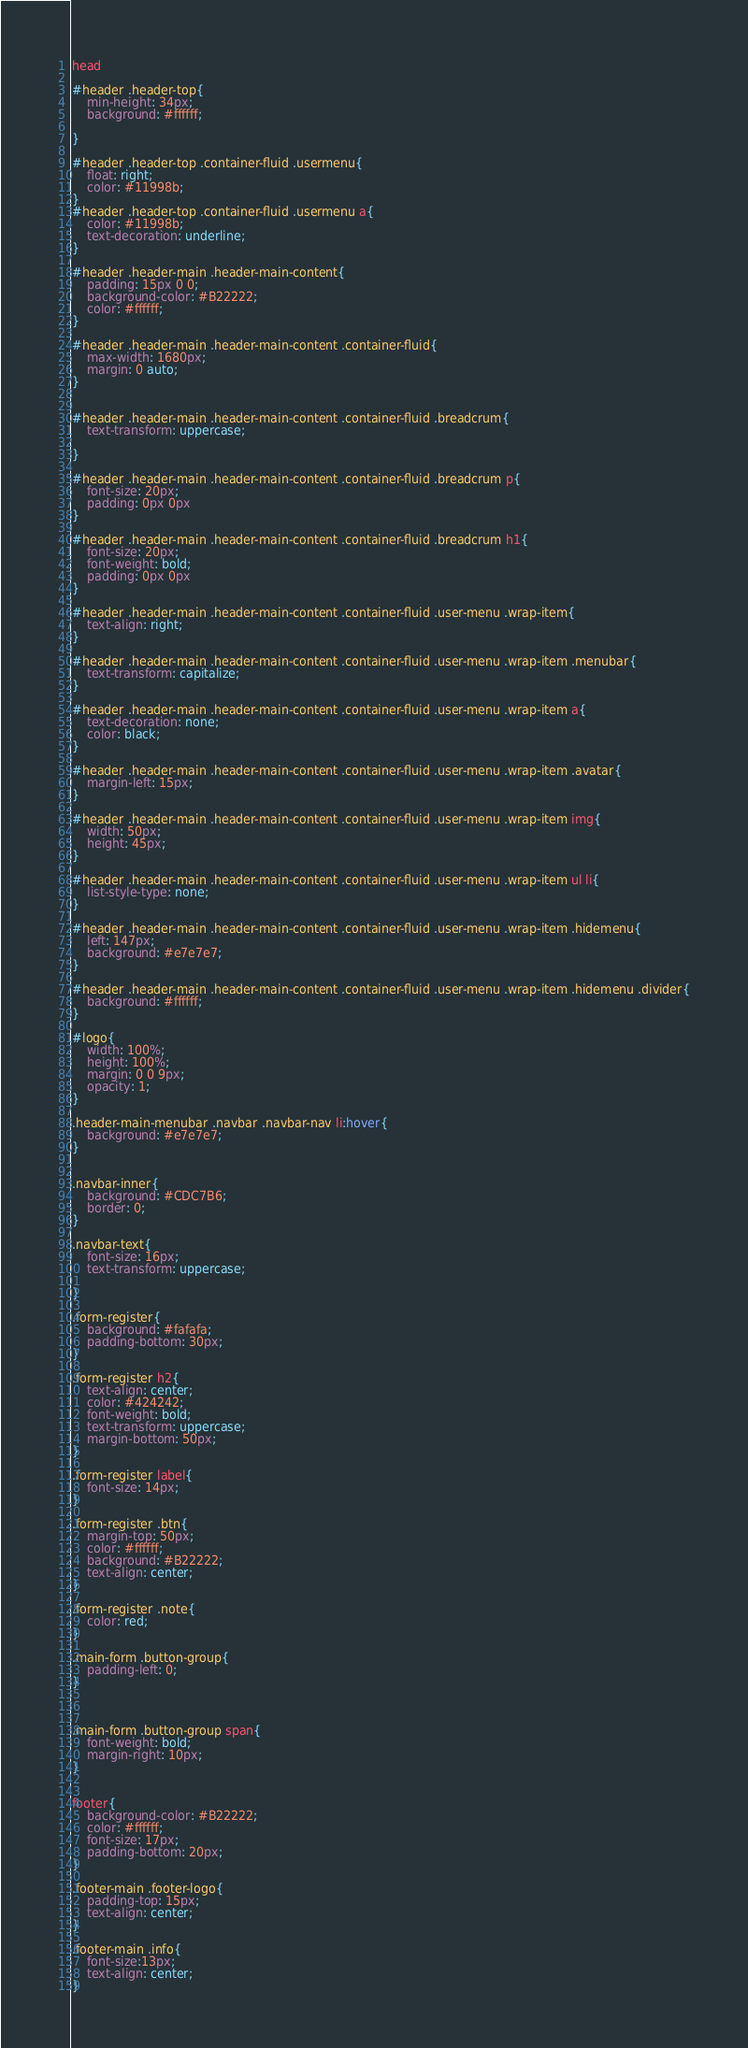Convert code to text. <code><loc_0><loc_0><loc_500><loc_500><_CSS_>head

#header .header-top{
	min-height: 34px;
    background: #ffffff;
    
}

#header .header-top .container-fluid .usermenu{
	float: right;
	color: #11998b;
}
#header .header-top .container-fluid .usermenu a{
	color: #11998b;
	text-decoration: underline;
}

#header .header-main .header-main-content{
	padding: 15px 0 0;
	background-color: #B22222;
	color: #ffffff;
}

#header .header-main .header-main-content .container-fluid{
	max-width: 1680px;
    margin: 0 auto;
}


#header .header-main .header-main-content .container-fluid .breadcrum{
	text-transform: uppercase;
	
}

#header .header-main .header-main-content .container-fluid .breadcrum p{
	font-size: 20px;
	padding: 0px 0px 
}

#header .header-main .header-main-content .container-fluid .breadcrum h1{
	font-size: 20px;
	font-weight: bold;
	padding: 0px 0px 
}

#header .header-main .header-main-content .container-fluid .user-menu .wrap-item{
	text-align: right;
}

#header .header-main .header-main-content .container-fluid .user-menu .wrap-item .menubar{
	text-transform: capitalize;
}

#header .header-main .header-main-content .container-fluid .user-menu .wrap-item a{
	text-decoration: none;
	color: black;
}

#header .header-main .header-main-content .container-fluid .user-menu .wrap-item .avatar{
	margin-left: 15px;
}

#header .header-main .header-main-content .container-fluid .user-menu .wrap-item img{
	width: 50px;
	height: 45px;
}

#header .header-main .header-main-content .container-fluid .user-menu .wrap-item ul li{
	list-style-type: none;
}

#header .header-main .header-main-content .container-fluid .user-menu .wrap-item .hidemenu{
	left: 147px;
	background: #e7e7e7;
}

#header .header-main .header-main-content .container-fluid .user-menu .wrap-item .hidemenu .divider{
	background: #ffffff;
}

#logo{
	width: 100%;
    height: 100%;
    margin: 0 0 9px;
    opacity: 1;
}

.header-main-menubar .navbar .navbar-nav li:hover{
	background: #e7e7e7;
}


.navbar-inner{
	background: #CDC7B6;
    border: 0;
}

.navbar-text{
	font-size: 16px;
	text-transform: uppercase;

}

.form-register{
	background: #fafafa;
    padding-bottom: 30px;
}

.form-register h2{
	text-align: center;
	color: #424242;
	font-weight: bold;
	text-transform: uppercase;
	margin-bottom: 50px;
}

.form-register label{
	font-size: 14px;
}

.form-register .btn{
	margin-top: 50px;
	color: #ffffff;
	background: #B22222;
	text-align: center;
}

.form-register .note{
	color: red;
}

.main-form .button-group{
	padding-left: 0;
}



.main-form .button-group span{
	font-weight: bold;
	margin-right: 10px;
}


footer{
	background-color: #B22222;
	color: #ffffff;
	font-size: 17px;
	padding-bottom: 20px;
}

.footer-main .footer-logo{
	padding-top: 15px;
	text-align: center;
}

.footer-main .info{
	font-size:13px; 
	text-align: center;
}</code> 